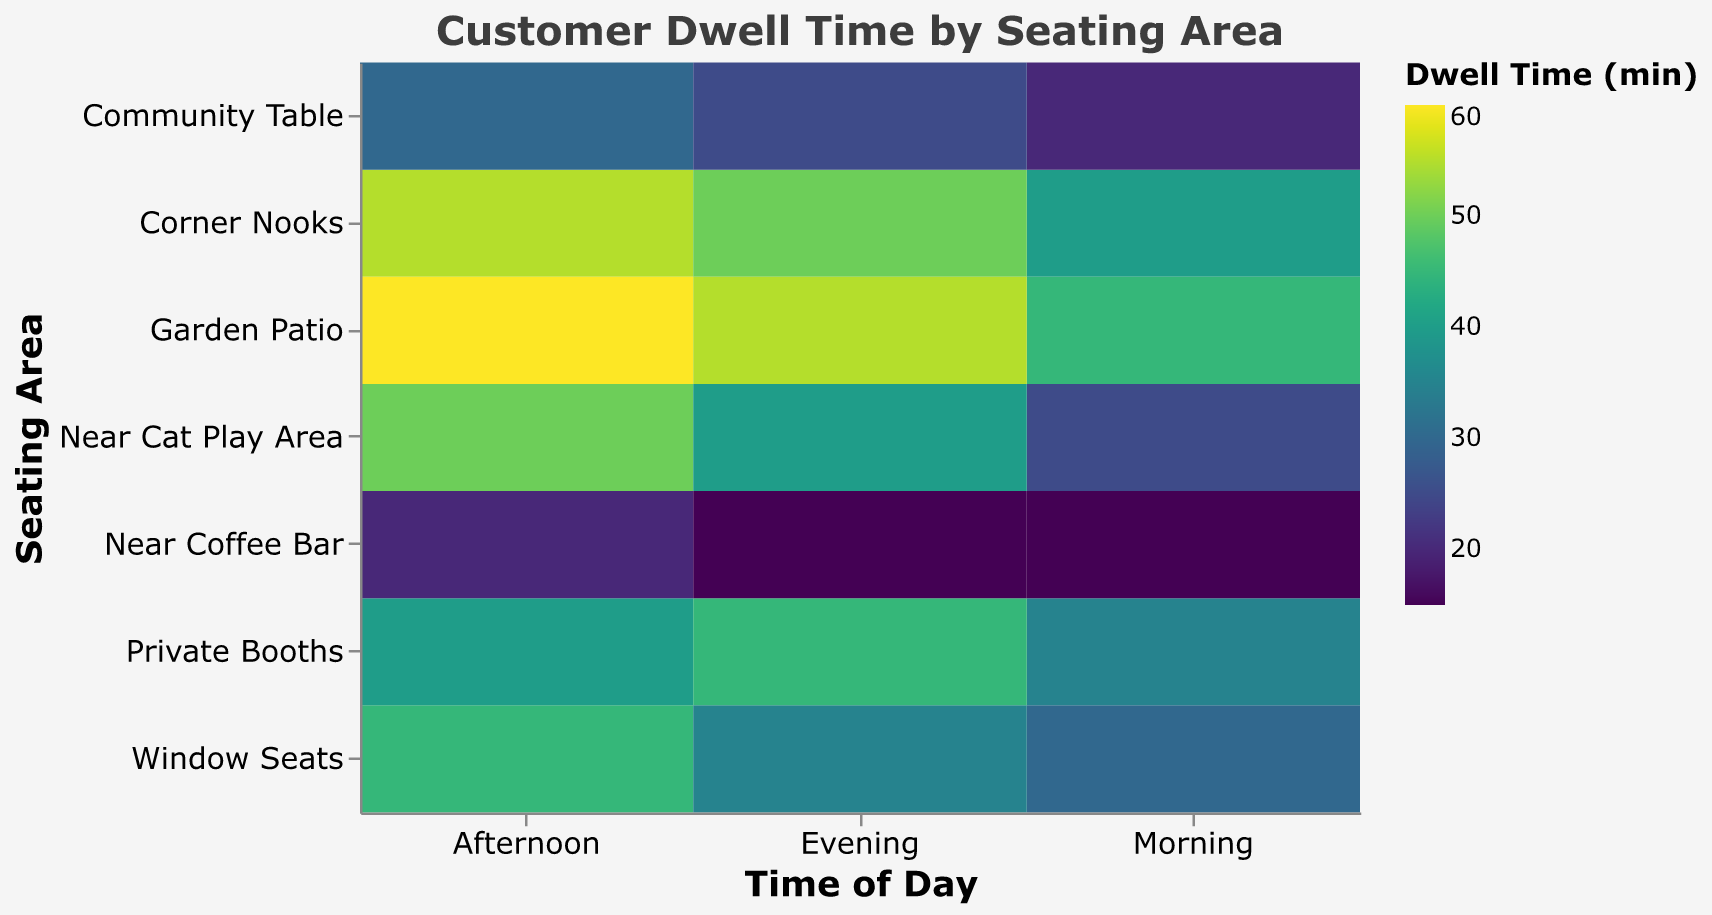What is the title of the figure? The title is located at the top of the heatmap and provides a clear description of what the figure represents.
Answer: Customer Dwell Time by Seating Area Which seating area has the highest average dwell time across all times of the day? To find this, calculate the average for each seating area across Morning, Afternoon, and Evening, then identify the highest. Garden Patio has an average (45+60+55)/3 = 53.3 minutes, which is the highest.
Answer: Garden Patio In which seating area do customers spend the least amount of time in the morning? Look at the Morning column, and find the smallest value among the seating areas. The minimum dwell time in the Morning is 15 minutes at Near Coffee Bar.
Answer: Near Coffee Bar Compare the dwell time in Corner Nooks and Community Table during the afternoon, which one is higher? Check the Afternoon column for both seating areas. Corner Nooks have a dwell time of 55 minutes, Community Table has 30 minutes.
Answer: Corner Nooks Which time of day do customers tend to spend the most time at the Near Cat Play Area? Check the dwell times for Near Cat Play Area across Morning, Afternoon, and Evening. The highest value is 50 minutes in the Afternoon.
Answer: Afternoon What is the average dwell time in Private Booths across all times of the day? Sum the dwell times for Private Booths across Morning, Afternoon, and Evening, then divide by 3: (35+40+45)/3 = 40.
Answer: 40 Do customers spend more time at Window Seats in the evening or at Private Booths in the morning? Compare the dwell time for Window Seats in the Evening (35 minutes) with Private Booths in the Morning (35 minutes). They are equal.
Answer: Equal Which seating area shows the largest difference in dwell time between Morning and Afternoon? Calculate the difference between Morning and Afternoon for each seating area and identify the largest difference. Garden Patio: 60 - 45 = 15 min (largest difference).
Answer: Garden Patio How does the evening dwell time in Window Seats compare to the average evening dwell time for all areas? First, calculate the average Evening dwell time for all areas, then compare it with Window Seats. Average Evening = (35+40+50+25+45+15+55)/7 ≈ 37.14. Window Seats: 35 minutes (lower than the average).
Answer: Lower Which seating area do customers spend the longest time in during the afternoon? Check the Afternoon column for the highest dwell time. Garden Patio has the longest dwell time in the Afternoon with 60 minutes.
Answer: Garden Patio 